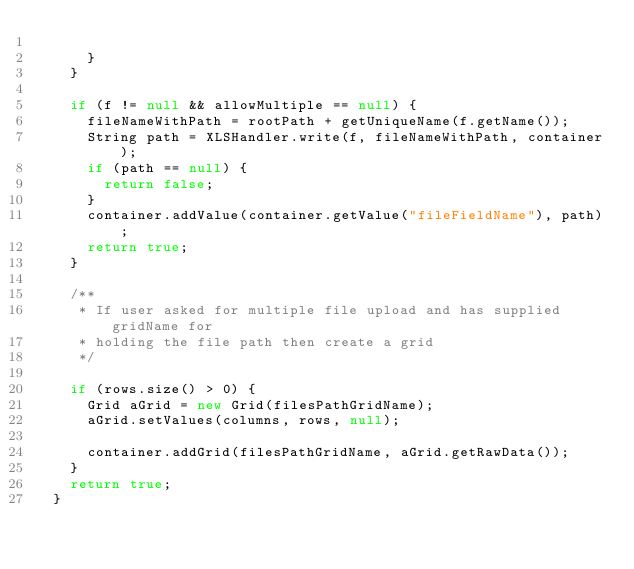Convert code to text. <code><loc_0><loc_0><loc_500><loc_500><_Java_>
			}
		}

		if (f != null && allowMultiple == null) {
			fileNameWithPath = rootPath + getUniqueName(f.getName());
			String path = XLSHandler.write(f, fileNameWithPath, container);
			if (path == null) {
				return false;
			}
			container.addValue(container.getValue("fileFieldName"), path);
			return true;
		}

		/**
		 * If user asked for multiple file upload and has supplied gridName for
		 * holding the file path then create a grid
		 */

		if (rows.size() > 0) {
			Grid aGrid = new Grid(filesPathGridName);
			aGrid.setValues(columns, rows, null);

			container.addGrid(filesPathGridName, aGrid.getRawData());
		}
		return true;
	}
</code> 